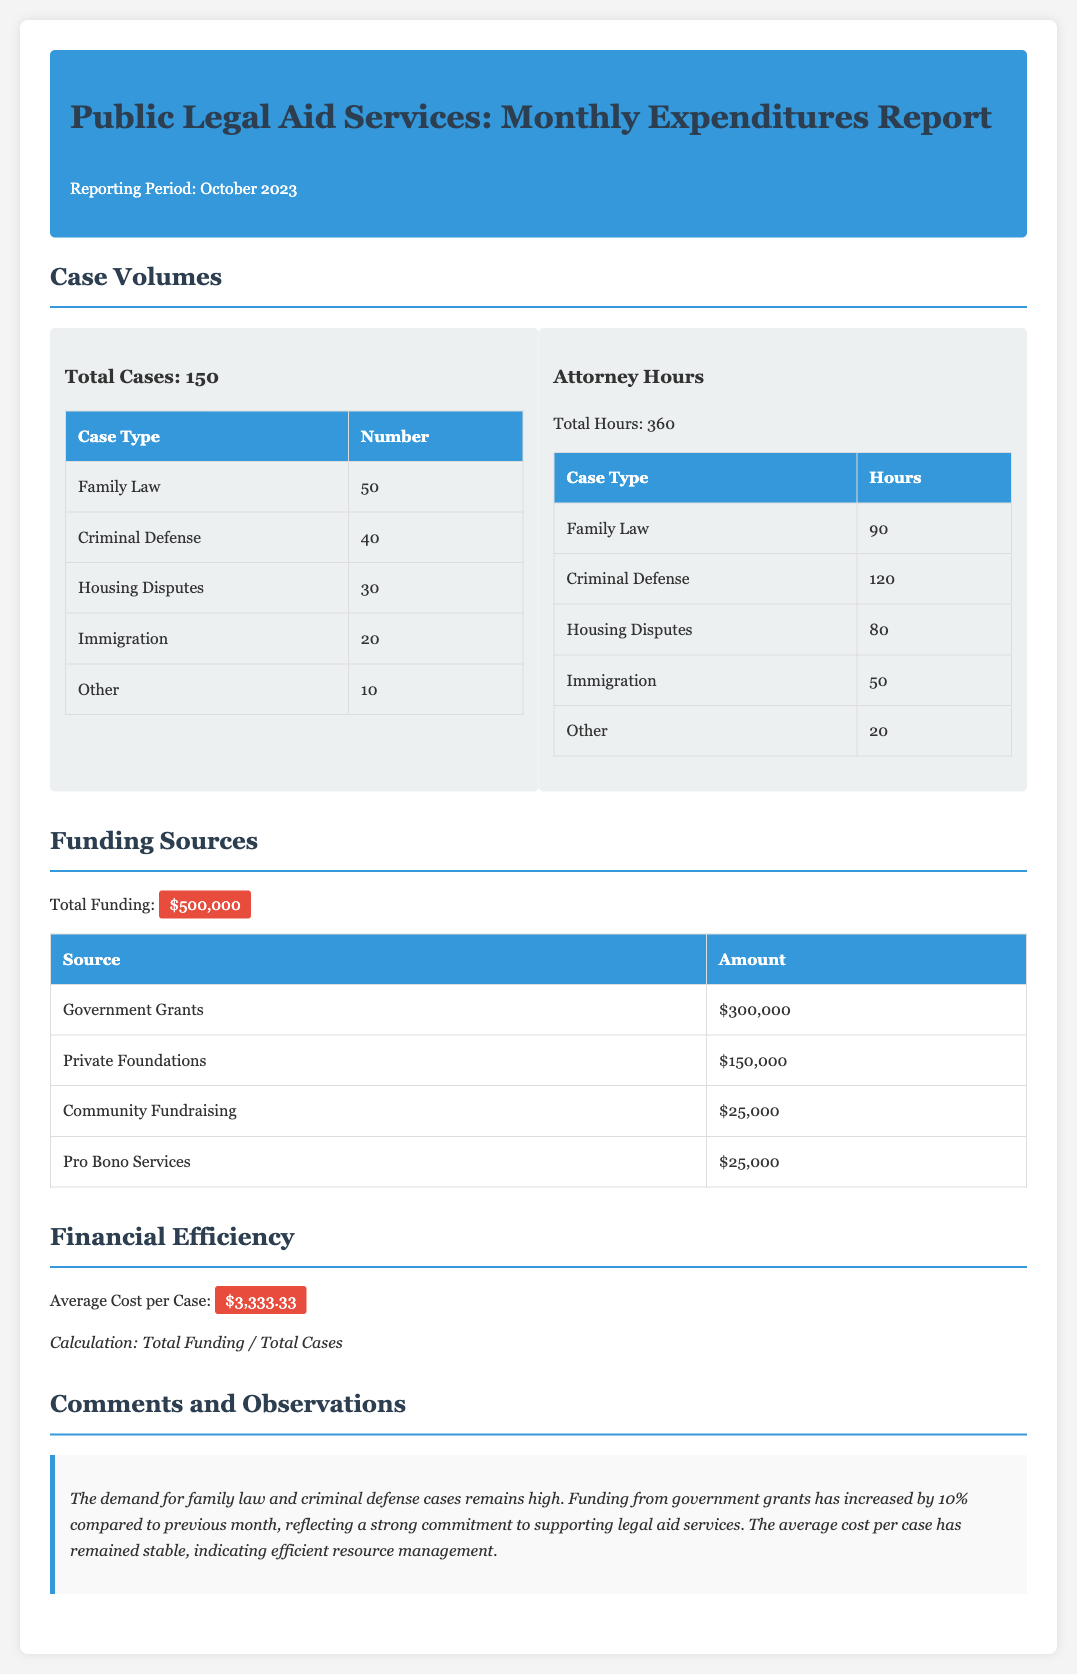What is the total number of cases? The total number of cases is explicitly stated in the report section on Case Volumes.
Answer: 150 How many attorney hours were spent on Criminal Defense? The specific number of attorney hours for Criminal Defense is provided in the Attorney Hours table of the report.
Answer: 120 What is the funding amount from Private Foundations? The report lists the amount contributed by Private Foundations in the Funding Sources section.
Answer: $150,000 What is the average cost per case? The Average Cost per Case is calculated and displayed in the Financial Efficiency section of the document.
Answer: $3,333.33 Which case type has the highest number of cases? The document reveals the case type with the highest volume in the Case Volumes section.
Answer: Family Law What percentage increase in government grants is reported compared to the previous month? The report mentions the increase percentage of government grants in the Comments and Observations section.
Answer: 10% What is the total funding amount? The total funding is summarized in the Funding Sources section where all funding contributions are combined.
Answer: $500,000 How many cases were categorized as Immigration? The number of Immigration cases is specified in the Case Volumes table within the report.
Answer: 20 What aspect of resource management does the report highlight? The report emphasizes the efficiency in resource management in the Comments and Observations section.
Answer: Stable Average Cost per Case 